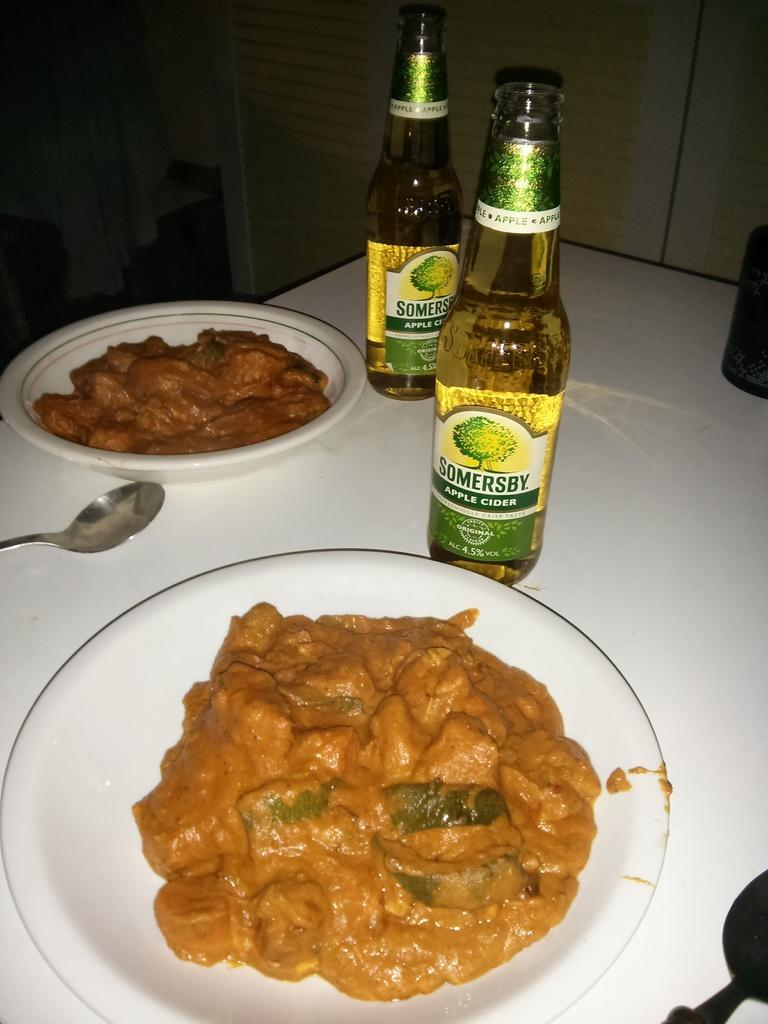<image>
Describe the image concisely. A bowl of food sits in front of a bottle of Somersby apple cider. 